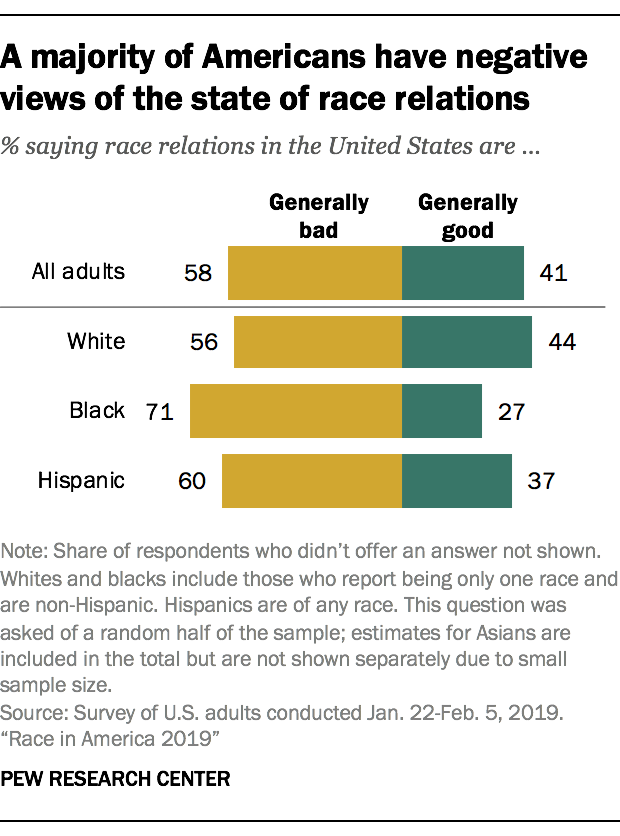Identify some key points in this picture. According to a survey, a significant percentage of all adults believe that race relations are bad. Specifically, 58% of adults have this opinion. The gap between white and black people who see race relations as good is 17%. 